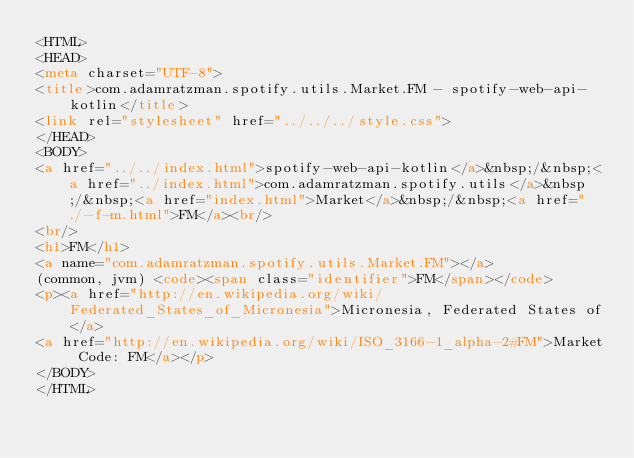<code> <loc_0><loc_0><loc_500><loc_500><_HTML_><HTML>
<HEAD>
<meta charset="UTF-8">
<title>com.adamratzman.spotify.utils.Market.FM - spotify-web-api-kotlin</title>
<link rel="stylesheet" href="../../../style.css">
</HEAD>
<BODY>
<a href="../../index.html">spotify-web-api-kotlin</a>&nbsp;/&nbsp;<a href="../index.html">com.adamratzman.spotify.utils</a>&nbsp;/&nbsp;<a href="index.html">Market</a>&nbsp;/&nbsp;<a href="./-f-m.html">FM</a><br/>
<br/>
<h1>FM</h1>
<a name="com.adamratzman.spotify.utils.Market.FM"></a>
(common, jvm) <code><span class="identifier">FM</span></code>
<p><a href="http://en.wikipedia.org/wiki/Federated_States_of_Micronesia">Micronesia, Federated States of</a>
<a href="http://en.wikipedia.org/wiki/ISO_3166-1_alpha-2#FM">Market Code: FM</a></p>
</BODY>
</HTML>
</code> 